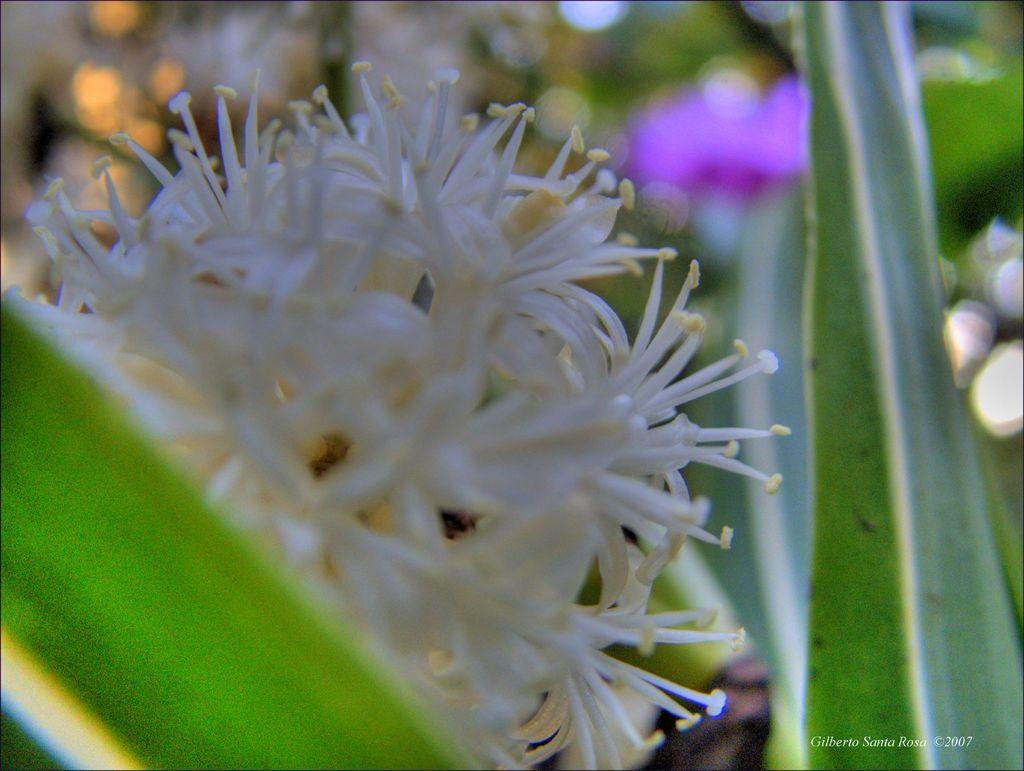What is the main subject of the image? There is a flower in the image. Can you describe the colors of the flower? The flower has white and yellow colors. What else can be seen in the image besides the flower? There are other plants in the background of the image. How is the background of the image depicted? The background is blurred. What type of acoustics can be heard in the image? There is no sound or acoustics present in the image, as it is a still photograph of a flower and other plants. Is there anyone coughing in the image? There are no people or animals present in the image, so there is no coughing or any other sound being made. 